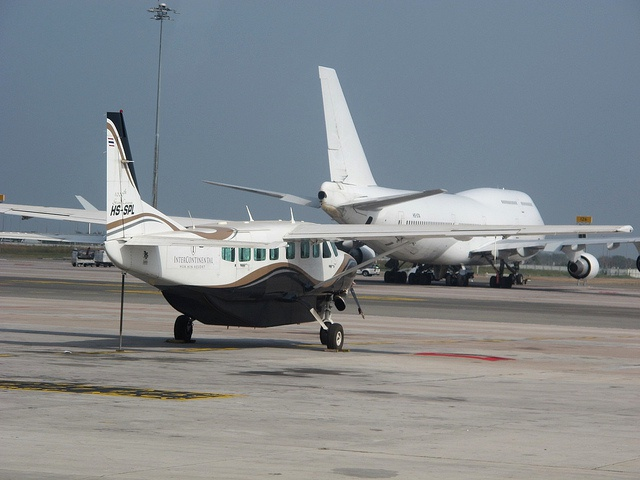Describe the objects in this image and their specific colors. I can see airplane in gray, lightgray, black, and darkgray tones, airplane in gray, lightgray, and darkgray tones, truck in gray, black, and darkgray tones, and truck in gray, black, darkgray, and lightgray tones in this image. 